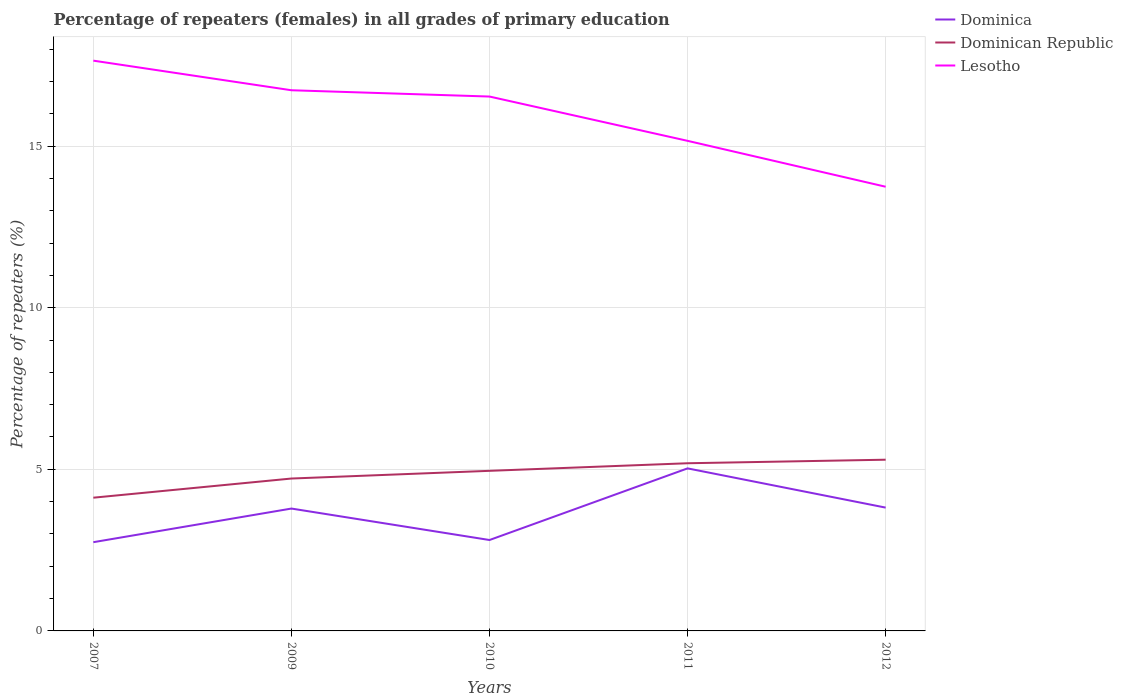How many different coloured lines are there?
Your answer should be very brief. 3. Is the number of lines equal to the number of legend labels?
Offer a very short reply. Yes. Across all years, what is the maximum percentage of repeaters (females) in Dominican Republic?
Your response must be concise. 4.12. In which year was the percentage of repeaters (females) in Dominican Republic maximum?
Provide a short and direct response. 2007. What is the total percentage of repeaters (females) in Lesotho in the graph?
Provide a succinct answer. 2.48. What is the difference between the highest and the second highest percentage of repeaters (females) in Lesotho?
Your response must be concise. 3.9. What is the difference between the highest and the lowest percentage of repeaters (females) in Dominican Republic?
Offer a very short reply. 3. Is the percentage of repeaters (females) in Dominican Republic strictly greater than the percentage of repeaters (females) in Lesotho over the years?
Provide a short and direct response. Yes. How many lines are there?
Make the answer very short. 3. How many legend labels are there?
Your response must be concise. 3. What is the title of the graph?
Make the answer very short. Percentage of repeaters (females) in all grades of primary education. What is the label or title of the X-axis?
Your response must be concise. Years. What is the label or title of the Y-axis?
Make the answer very short. Percentage of repeaters (%). What is the Percentage of repeaters (%) of Dominica in 2007?
Your response must be concise. 2.75. What is the Percentage of repeaters (%) in Dominican Republic in 2007?
Make the answer very short. 4.12. What is the Percentage of repeaters (%) of Lesotho in 2007?
Make the answer very short. 17.64. What is the Percentage of repeaters (%) in Dominica in 2009?
Keep it short and to the point. 3.79. What is the Percentage of repeaters (%) of Dominican Republic in 2009?
Provide a succinct answer. 4.71. What is the Percentage of repeaters (%) in Lesotho in 2009?
Offer a terse response. 16.73. What is the Percentage of repeaters (%) in Dominica in 2010?
Provide a succinct answer. 2.81. What is the Percentage of repeaters (%) in Dominican Republic in 2010?
Your answer should be compact. 4.95. What is the Percentage of repeaters (%) in Lesotho in 2010?
Offer a terse response. 16.53. What is the Percentage of repeaters (%) of Dominica in 2011?
Keep it short and to the point. 5.03. What is the Percentage of repeaters (%) of Dominican Republic in 2011?
Offer a terse response. 5.19. What is the Percentage of repeaters (%) of Lesotho in 2011?
Provide a succinct answer. 15.16. What is the Percentage of repeaters (%) of Dominica in 2012?
Ensure brevity in your answer.  3.82. What is the Percentage of repeaters (%) of Dominican Republic in 2012?
Keep it short and to the point. 5.3. What is the Percentage of repeaters (%) of Lesotho in 2012?
Your answer should be compact. 13.74. Across all years, what is the maximum Percentage of repeaters (%) in Dominica?
Keep it short and to the point. 5.03. Across all years, what is the maximum Percentage of repeaters (%) of Dominican Republic?
Keep it short and to the point. 5.3. Across all years, what is the maximum Percentage of repeaters (%) in Lesotho?
Your answer should be very brief. 17.64. Across all years, what is the minimum Percentage of repeaters (%) of Dominica?
Your answer should be very brief. 2.75. Across all years, what is the minimum Percentage of repeaters (%) in Dominican Republic?
Offer a very short reply. 4.12. Across all years, what is the minimum Percentage of repeaters (%) in Lesotho?
Ensure brevity in your answer.  13.74. What is the total Percentage of repeaters (%) in Dominica in the graph?
Your answer should be very brief. 18.19. What is the total Percentage of repeaters (%) in Dominican Republic in the graph?
Your answer should be compact. 24.27. What is the total Percentage of repeaters (%) of Lesotho in the graph?
Make the answer very short. 79.81. What is the difference between the Percentage of repeaters (%) in Dominica in 2007 and that in 2009?
Your answer should be very brief. -1.04. What is the difference between the Percentage of repeaters (%) in Dominican Republic in 2007 and that in 2009?
Make the answer very short. -0.59. What is the difference between the Percentage of repeaters (%) in Lesotho in 2007 and that in 2009?
Offer a very short reply. 0.92. What is the difference between the Percentage of repeaters (%) of Dominica in 2007 and that in 2010?
Provide a succinct answer. -0.07. What is the difference between the Percentage of repeaters (%) in Dominican Republic in 2007 and that in 2010?
Keep it short and to the point. -0.83. What is the difference between the Percentage of repeaters (%) of Lesotho in 2007 and that in 2010?
Your answer should be very brief. 1.11. What is the difference between the Percentage of repeaters (%) in Dominica in 2007 and that in 2011?
Keep it short and to the point. -2.28. What is the difference between the Percentage of repeaters (%) of Dominican Republic in 2007 and that in 2011?
Provide a short and direct response. -1.07. What is the difference between the Percentage of repeaters (%) in Lesotho in 2007 and that in 2011?
Keep it short and to the point. 2.48. What is the difference between the Percentage of repeaters (%) of Dominica in 2007 and that in 2012?
Provide a succinct answer. -1.07. What is the difference between the Percentage of repeaters (%) in Dominican Republic in 2007 and that in 2012?
Provide a succinct answer. -1.18. What is the difference between the Percentage of repeaters (%) of Lesotho in 2007 and that in 2012?
Your answer should be very brief. 3.9. What is the difference between the Percentage of repeaters (%) of Dominica in 2009 and that in 2010?
Provide a short and direct response. 0.97. What is the difference between the Percentage of repeaters (%) of Dominican Republic in 2009 and that in 2010?
Keep it short and to the point. -0.24. What is the difference between the Percentage of repeaters (%) of Lesotho in 2009 and that in 2010?
Provide a short and direct response. 0.19. What is the difference between the Percentage of repeaters (%) of Dominica in 2009 and that in 2011?
Give a very brief answer. -1.24. What is the difference between the Percentage of repeaters (%) in Dominican Republic in 2009 and that in 2011?
Provide a succinct answer. -0.47. What is the difference between the Percentage of repeaters (%) of Lesotho in 2009 and that in 2011?
Offer a terse response. 1.57. What is the difference between the Percentage of repeaters (%) of Dominica in 2009 and that in 2012?
Provide a succinct answer. -0.03. What is the difference between the Percentage of repeaters (%) in Dominican Republic in 2009 and that in 2012?
Provide a succinct answer. -0.58. What is the difference between the Percentage of repeaters (%) of Lesotho in 2009 and that in 2012?
Provide a short and direct response. 2.98. What is the difference between the Percentage of repeaters (%) in Dominica in 2010 and that in 2011?
Your response must be concise. -2.22. What is the difference between the Percentage of repeaters (%) in Dominican Republic in 2010 and that in 2011?
Make the answer very short. -0.23. What is the difference between the Percentage of repeaters (%) in Lesotho in 2010 and that in 2011?
Your answer should be very brief. 1.37. What is the difference between the Percentage of repeaters (%) of Dominica in 2010 and that in 2012?
Your answer should be very brief. -1. What is the difference between the Percentage of repeaters (%) of Dominican Republic in 2010 and that in 2012?
Give a very brief answer. -0.34. What is the difference between the Percentage of repeaters (%) of Lesotho in 2010 and that in 2012?
Your answer should be compact. 2.79. What is the difference between the Percentage of repeaters (%) in Dominica in 2011 and that in 2012?
Your answer should be very brief. 1.21. What is the difference between the Percentage of repeaters (%) in Dominican Republic in 2011 and that in 2012?
Your answer should be very brief. -0.11. What is the difference between the Percentage of repeaters (%) of Lesotho in 2011 and that in 2012?
Give a very brief answer. 1.42. What is the difference between the Percentage of repeaters (%) in Dominica in 2007 and the Percentage of repeaters (%) in Dominican Republic in 2009?
Offer a terse response. -1.97. What is the difference between the Percentage of repeaters (%) in Dominica in 2007 and the Percentage of repeaters (%) in Lesotho in 2009?
Make the answer very short. -13.98. What is the difference between the Percentage of repeaters (%) of Dominican Republic in 2007 and the Percentage of repeaters (%) of Lesotho in 2009?
Provide a short and direct response. -12.61. What is the difference between the Percentage of repeaters (%) in Dominica in 2007 and the Percentage of repeaters (%) in Dominican Republic in 2010?
Make the answer very short. -2.21. What is the difference between the Percentage of repeaters (%) of Dominica in 2007 and the Percentage of repeaters (%) of Lesotho in 2010?
Offer a terse response. -13.79. What is the difference between the Percentage of repeaters (%) of Dominican Republic in 2007 and the Percentage of repeaters (%) of Lesotho in 2010?
Provide a short and direct response. -12.41. What is the difference between the Percentage of repeaters (%) in Dominica in 2007 and the Percentage of repeaters (%) in Dominican Republic in 2011?
Your answer should be compact. -2.44. What is the difference between the Percentage of repeaters (%) in Dominica in 2007 and the Percentage of repeaters (%) in Lesotho in 2011?
Ensure brevity in your answer.  -12.42. What is the difference between the Percentage of repeaters (%) in Dominican Republic in 2007 and the Percentage of repeaters (%) in Lesotho in 2011?
Give a very brief answer. -11.04. What is the difference between the Percentage of repeaters (%) in Dominica in 2007 and the Percentage of repeaters (%) in Dominican Republic in 2012?
Offer a terse response. -2.55. What is the difference between the Percentage of repeaters (%) of Dominica in 2007 and the Percentage of repeaters (%) of Lesotho in 2012?
Offer a very short reply. -11. What is the difference between the Percentage of repeaters (%) of Dominican Republic in 2007 and the Percentage of repeaters (%) of Lesotho in 2012?
Provide a short and direct response. -9.62. What is the difference between the Percentage of repeaters (%) in Dominica in 2009 and the Percentage of repeaters (%) in Dominican Republic in 2010?
Your answer should be very brief. -1.17. What is the difference between the Percentage of repeaters (%) of Dominica in 2009 and the Percentage of repeaters (%) of Lesotho in 2010?
Give a very brief answer. -12.75. What is the difference between the Percentage of repeaters (%) in Dominican Republic in 2009 and the Percentage of repeaters (%) in Lesotho in 2010?
Your answer should be compact. -11.82. What is the difference between the Percentage of repeaters (%) in Dominica in 2009 and the Percentage of repeaters (%) in Dominican Republic in 2011?
Your answer should be compact. -1.4. What is the difference between the Percentage of repeaters (%) of Dominica in 2009 and the Percentage of repeaters (%) of Lesotho in 2011?
Give a very brief answer. -11.38. What is the difference between the Percentage of repeaters (%) of Dominican Republic in 2009 and the Percentage of repeaters (%) of Lesotho in 2011?
Offer a terse response. -10.45. What is the difference between the Percentage of repeaters (%) of Dominica in 2009 and the Percentage of repeaters (%) of Dominican Republic in 2012?
Your answer should be very brief. -1.51. What is the difference between the Percentage of repeaters (%) of Dominica in 2009 and the Percentage of repeaters (%) of Lesotho in 2012?
Ensure brevity in your answer.  -9.96. What is the difference between the Percentage of repeaters (%) of Dominican Republic in 2009 and the Percentage of repeaters (%) of Lesotho in 2012?
Your response must be concise. -9.03. What is the difference between the Percentage of repeaters (%) of Dominica in 2010 and the Percentage of repeaters (%) of Dominican Republic in 2011?
Keep it short and to the point. -2.37. What is the difference between the Percentage of repeaters (%) in Dominica in 2010 and the Percentage of repeaters (%) in Lesotho in 2011?
Give a very brief answer. -12.35. What is the difference between the Percentage of repeaters (%) in Dominican Republic in 2010 and the Percentage of repeaters (%) in Lesotho in 2011?
Offer a very short reply. -10.21. What is the difference between the Percentage of repeaters (%) of Dominica in 2010 and the Percentage of repeaters (%) of Dominican Republic in 2012?
Your answer should be very brief. -2.48. What is the difference between the Percentage of repeaters (%) in Dominica in 2010 and the Percentage of repeaters (%) in Lesotho in 2012?
Keep it short and to the point. -10.93. What is the difference between the Percentage of repeaters (%) of Dominican Republic in 2010 and the Percentage of repeaters (%) of Lesotho in 2012?
Give a very brief answer. -8.79. What is the difference between the Percentage of repeaters (%) in Dominica in 2011 and the Percentage of repeaters (%) in Dominican Republic in 2012?
Your answer should be very brief. -0.27. What is the difference between the Percentage of repeaters (%) in Dominica in 2011 and the Percentage of repeaters (%) in Lesotho in 2012?
Ensure brevity in your answer.  -8.71. What is the difference between the Percentage of repeaters (%) in Dominican Republic in 2011 and the Percentage of repeaters (%) in Lesotho in 2012?
Your response must be concise. -8.56. What is the average Percentage of repeaters (%) of Dominica per year?
Offer a terse response. 3.64. What is the average Percentage of repeaters (%) of Dominican Republic per year?
Your answer should be compact. 4.86. What is the average Percentage of repeaters (%) of Lesotho per year?
Offer a very short reply. 15.96. In the year 2007, what is the difference between the Percentage of repeaters (%) in Dominica and Percentage of repeaters (%) in Dominican Republic?
Provide a succinct answer. -1.38. In the year 2007, what is the difference between the Percentage of repeaters (%) of Dominica and Percentage of repeaters (%) of Lesotho?
Keep it short and to the point. -14.9. In the year 2007, what is the difference between the Percentage of repeaters (%) in Dominican Republic and Percentage of repeaters (%) in Lesotho?
Keep it short and to the point. -13.52. In the year 2009, what is the difference between the Percentage of repeaters (%) of Dominica and Percentage of repeaters (%) of Dominican Republic?
Your answer should be compact. -0.93. In the year 2009, what is the difference between the Percentage of repeaters (%) in Dominica and Percentage of repeaters (%) in Lesotho?
Keep it short and to the point. -12.94. In the year 2009, what is the difference between the Percentage of repeaters (%) of Dominican Republic and Percentage of repeaters (%) of Lesotho?
Offer a very short reply. -12.01. In the year 2010, what is the difference between the Percentage of repeaters (%) in Dominica and Percentage of repeaters (%) in Dominican Republic?
Ensure brevity in your answer.  -2.14. In the year 2010, what is the difference between the Percentage of repeaters (%) in Dominica and Percentage of repeaters (%) in Lesotho?
Provide a succinct answer. -13.72. In the year 2010, what is the difference between the Percentage of repeaters (%) of Dominican Republic and Percentage of repeaters (%) of Lesotho?
Your answer should be compact. -11.58. In the year 2011, what is the difference between the Percentage of repeaters (%) in Dominica and Percentage of repeaters (%) in Dominican Republic?
Provide a succinct answer. -0.16. In the year 2011, what is the difference between the Percentage of repeaters (%) in Dominica and Percentage of repeaters (%) in Lesotho?
Give a very brief answer. -10.13. In the year 2011, what is the difference between the Percentage of repeaters (%) in Dominican Republic and Percentage of repeaters (%) in Lesotho?
Ensure brevity in your answer.  -9.98. In the year 2012, what is the difference between the Percentage of repeaters (%) of Dominica and Percentage of repeaters (%) of Dominican Republic?
Offer a very short reply. -1.48. In the year 2012, what is the difference between the Percentage of repeaters (%) of Dominica and Percentage of repeaters (%) of Lesotho?
Ensure brevity in your answer.  -9.93. In the year 2012, what is the difference between the Percentage of repeaters (%) of Dominican Republic and Percentage of repeaters (%) of Lesotho?
Your answer should be compact. -8.45. What is the ratio of the Percentage of repeaters (%) of Dominica in 2007 to that in 2009?
Offer a terse response. 0.73. What is the ratio of the Percentage of repeaters (%) in Dominican Republic in 2007 to that in 2009?
Provide a short and direct response. 0.87. What is the ratio of the Percentage of repeaters (%) of Lesotho in 2007 to that in 2009?
Provide a short and direct response. 1.05. What is the ratio of the Percentage of repeaters (%) in Dominica in 2007 to that in 2010?
Provide a succinct answer. 0.98. What is the ratio of the Percentage of repeaters (%) of Dominican Republic in 2007 to that in 2010?
Your answer should be very brief. 0.83. What is the ratio of the Percentage of repeaters (%) of Lesotho in 2007 to that in 2010?
Make the answer very short. 1.07. What is the ratio of the Percentage of repeaters (%) in Dominica in 2007 to that in 2011?
Offer a very short reply. 0.55. What is the ratio of the Percentage of repeaters (%) of Dominican Republic in 2007 to that in 2011?
Provide a succinct answer. 0.79. What is the ratio of the Percentage of repeaters (%) in Lesotho in 2007 to that in 2011?
Give a very brief answer. 1.16. What is the ratio of the Percentage of repeaters (%) in Dominica in 2007 to that in 2012?
Give a very brief answer. 0.72. What is the ratio of the Percentage of repeaters (%) in Dominican Republic in 2007 to that in 2012?
Offer a terse response. 0.78. What is the ratio of the Percentage of repeaters (%) of Lesotho in 2007 to that in 2012?
Make the answer very short. 1.28. What is the ratio of the Percentage of repeaters (%) in Dominica in 2009 to that in 2010?
Your answer should be compact. 1.35. What is the ratio of the Percentage of repeaters (%) in Dominican Republic in 2009 to that in 2010?
Give a very brief answer. 0.95. What is the ratio of the Percentage of repeaters (%) in Lesotho in 2009 to that in 2010?
Ensure brevity in your answer.  1.01. What is the ratio of the Percentage of repeaters (%) of Dominica in 2009 to that in 2011?
Keep it short and to the point. 0.75. What is the ratio of the Percentage of repeaters (%) in Dominican Republic in 2009 to that in 2011?
Offer a terse response. 0.91. What is the ratio of the Percentage of repeaters (%) of Lesotho in 2009 to that in 2011?
Make the answer very short. 1.1. What is the ratio of the Percentage of repeaters (%) of Dominica in 2009 to that in 2012?
Your answer should be compact. 0.99. What is the ratio of the Percentage of repeaters (%) of Dominican Republic in 2009 to that in 2012?
Offer a terse response. 0.89. What is the ratio of the Percentage of repeaters (%) of Lesotho in 2009 to that in 2012?
Your answer should be very brief. 1.22. What is the ratio of the Percentage of repeaters (%) of Dominica in 2010 to that in 2011?
Make the answer very short. 0.56. What is the ratio of the Percentage of repeaters (%) of Dominican Republic in 2010 to that in 2011?
Provide a short and direct response. 0.95. What is the ratio of the Percentage of repeaters (%) in Lesotho in 2010 to that in 2011?
Ensure brevity in your answer.  1.09. What is the ratio of the Percentage of repeaters (%) of Dominica in 2010 to that in 2012?
Provide a succinct answer. 0.74. What is the ratio of the Percentage of repeaters (%) in Dominican Republic in 2010 to that in 2012?
Provide a short and direct response. 0.94. What is the ratio of the Percentage of repeaters (%) of Lesotho in 2010 to that in 2012?
Ensure brevity in your answer.  1.2. What is the ratio of the Percentage of repeaters (%) in Dominica in 2011 to that in 2012?
Your answer should be very brief. 1.32. What is the ratio of the Percentage of repeaters (%) of Dominican Republic in 2011 to that in 2012?
Provide a succinct answer. 0.98. What is the ratio of the Percentage of repeaters (%) of Lesotho in 2011 to that in 2012?
Make the answer very short. 1.1. What is the difference between the highest and the second highest Percentage of repeaters (%) in Dominica?
Make the answer very short. 1.21. What is the difference between the highest and the second highest Percentage of repeaters (%) in Dominican Republic?
Offer a terse response. 0.11. What is the difference between the highest and the second highest Percentage of repeaters (%) in Lesotho?
Your answer should be compact. 0.92. What is the difference between the highest and the lowest Percentage of repeaters (%) of Dominica?
Your answer should be compact. 2.28. What is the difference between the highest and the lowest Percentage of repeaters (%) in Dominican Republic?
Your response must be concise. 1.18. What is the difference between the highest and the lowest Percentage of repeaters (%) of Lesotho?
Offer a terse response. 3.9. 